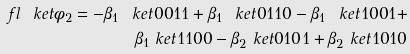<formula> <loc_0><loc_0><loc_500><loc_500>\ f l \ k e t { \phi _ { 2 } } = - \beta _ { 1 } \ k e t { 0 0 1 1 } + \beta _ { 1 } \ k e t { 0 1 1 0 } - \beta _ { 1 } \ k e t { 1 0 0 1 } + \\ \beta _ { 1 } \ k e t { 1 1 0 0 } - \beta _ { 2 } \ k e t { 0 1 0 1 } + \beta _ { 2 } \ k e t { 1 0 1 0 }</formula> 